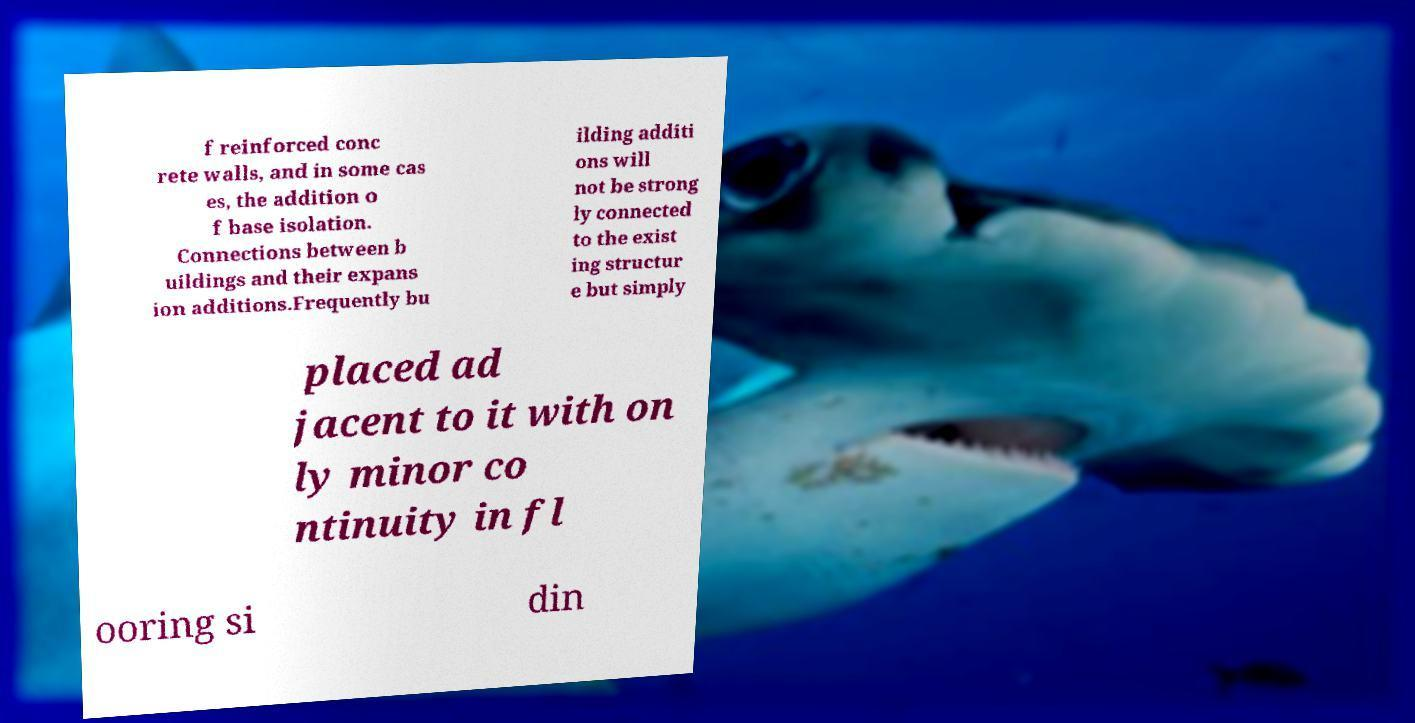What messages or text are displayed in this image? I need them in a readable, typed format. f reinforced conc rete walls, and in some cas es, the addition o f base isolation. Connections between b uildings and their expans ion additions.Frequently bu ilding additi ons will not be strong ly connected to the exist ing structur e but simply placed ad jacent to it with on ly minor co ntinuity in fl ooring si din 